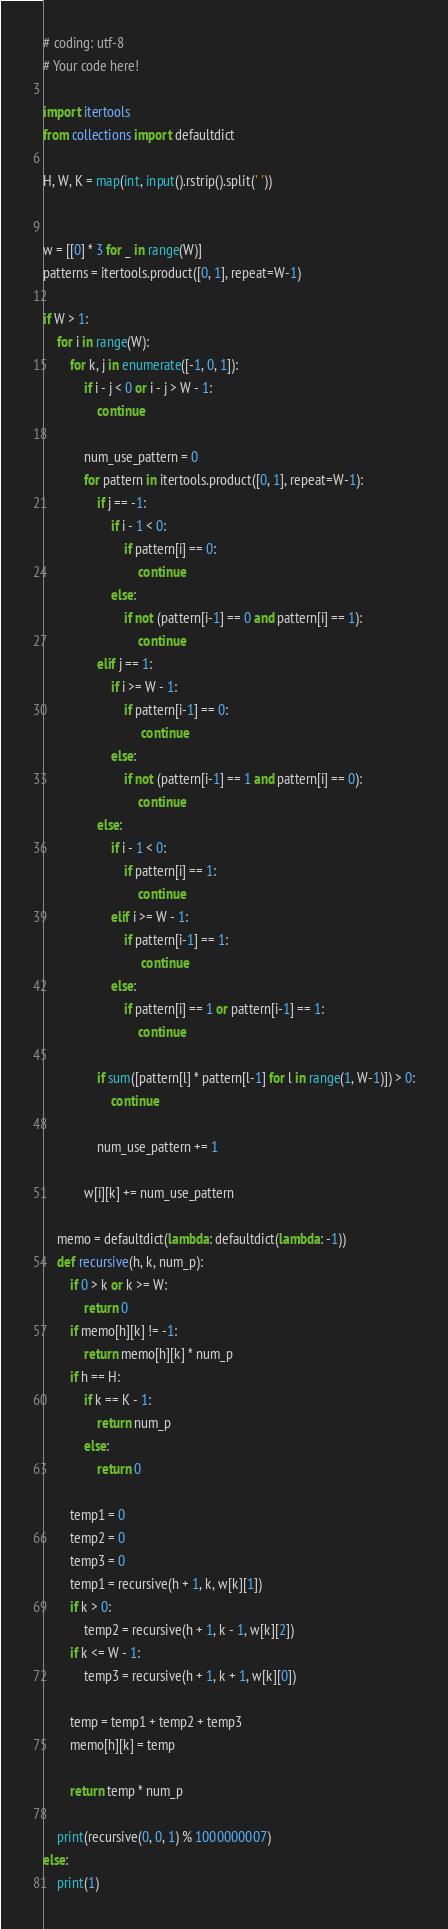<code> <loc_0><loc_0><loc_500><loc_500><_Python_># coding: utf-8
# Your code here!

import itertools 
from collections import defaultdict

H, W, K = map(int, input().rstrip().split(' '))


w = [[0] * 3 for _ in range(W)]
patterns = itertools.product([0, 1], repeat=W-1)

if W > 1:
    for i in range(W):
        for k, j in enumerate([-1, 0, 1]):
            if i - j < 0 or i - j > W - 1:
                continue
            
            num_use_pattern = 0
            for pattern in itertools.product([0, 1], repeat=W-1):
                if j == -1:
                    if i - 1 < 0: 
                        if pattern[i] == 0:
                            continue
                    else:
                        if not (pattern[i-1] == 0 and pattern[i] == 1):
                            continue
                elif j == 1:
                    if i >= W - 1:
                        if pattern[i-1] == 0:
                             continue
                    else:
                        if not (pattern[i-1] == 1 and pattern[i] == 0):
                            continue
                else:
                    if i - 1 < 0: 
                        if pattern[i] == 1:
                            continue
                    elif i >= W - 1:
                        if pattern[i-1] == 1:
                             continue
                    else:
                        if pattern[i] == 1 or pattern[i-1] == 1:
                            continue
                   
                if sum([pattern[l] * pattern[l-1] for l in range(1, W-1)]) > 0:
                    continue
                
                num_use_pattern += 1
                
            w[i][k] += num_use_pattern
     
    memo = defaultdict(lambda: defaultdict(lambda: -1))
    def recursive(h, k, num_p):
        if 0 > k or k >= W:
            return 0
        if memo[h][k] != -1:
            return memo[h][k] * num_p
        if h == H:
            if k == K - 1:
                return num_p
            else:
                return 0
             
        temp1 = 0
        temp2 = 0
        temp3 = 0
        temp1 = recursive(h + 1, k, w[k][1])
        if k > 0:
            temp2 = recursive(h + 1, k - 1, w[k][2])
        if k <= W - 1:
            temp3 = recursive(h + 1, k + 1, w[k][0])
            
        temp = temp1 + temp2 + temp3
        memo[h][k] = temp
        
        return temp * num_p
     
    print(recursive(0, 0, 1) % 1000000007)
else:
    print(1)
</code> 